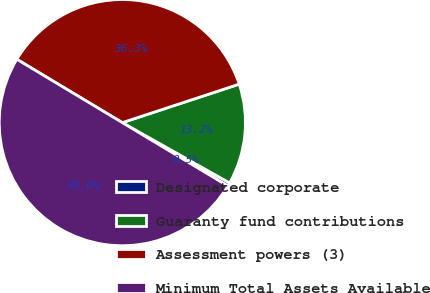Convert chart to OTSL. <chart><loc_0><loc_0><loc_500><loc_500><pie_chart><fcel>Designated corporate<fcel>Guaranty fund contributions<fcel>Assessment powers (3)<fcel>Minimum Total Assets Available<nl><fcel>0.46%<fcel>13.21%<fcel>36.33%<fcel>50.0%<nl></chart> 